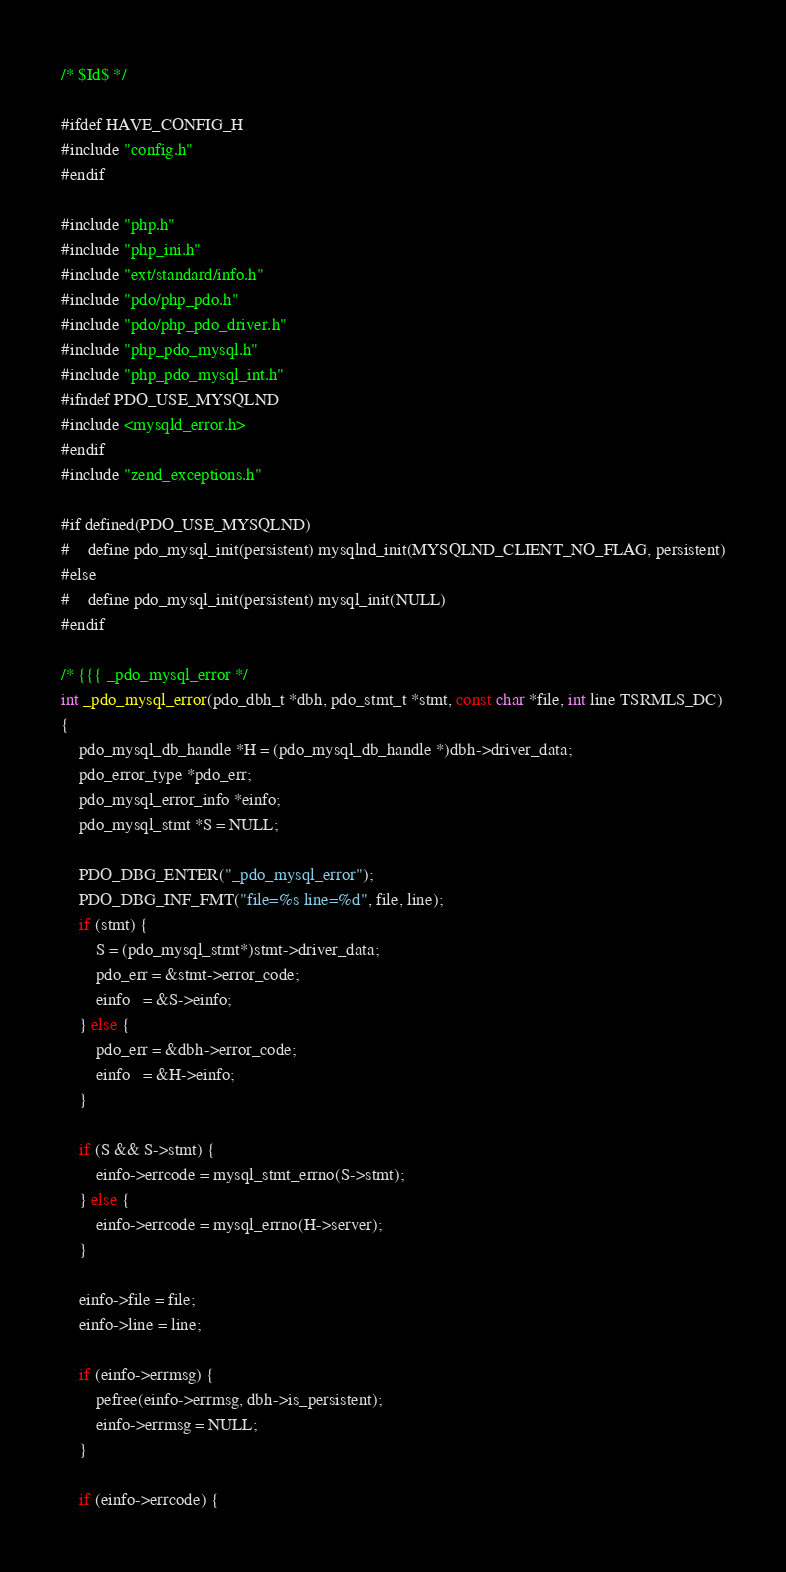<code> <loc_0><loc_0><loc_500><loc_500><_C_>
/* $Id$ */

#ifdef HAVE_CONFIG_H
#include "config.h"
#endif

#include "php.h"
#include "php_ini.h"
#include "ext/standard/info.h"
#include "pdo/php_pdo.h"
#include "pdo/php_pdo_driver.h"
#include "php_pdo_mysql.h"
#include "php_pdo_mysql_int.h"
#ifndef PDO_USE_MYSQLND
#include <mysqld_error.h>
#endif
#include "zend_exceptions.h"

#if defined(PDO_USE_MYSQLND)
#	define pdo_mysql_init(persistent) mysqlnd_init(MYSQLND_CLIENT_NO_FLAG, persistent)
#else
#	define pdo_mysql_init(persistent) mysql_init(NULL)
#endif

/* {{{ _pdo_mysql_error */
int _pdo_mysql_error(pdo_dbh_t *dbh, pdo_stmt_t *stmt, const char *file, int line TSRMLS_DC)
{
	pdo_mysql_db_handle *H = (pdo_mysql_db_handle *)dbh->driver_data;
	pdo_error_type *pdo_err; 
	pdo_mysql_error_info *einfo;
	pdo_mysql_stmt *S = NULL;

	PDO_DBG_ENTER("_pdo_mysql_error");
	PDO_DBG_INF_FMT("file=%s line=%d", file, line);
	if (stmt) {
		S = (pdo_mysql_stmt*)stmt->driver_data;
		pdo_err = &stmt->error_code;
		einfo   = &S->einfo;
	} else {
		pdo_err = &dbh->error_code;
		einfo   = &H->einfo;
	}

	if (S && S->stmt) {
		einfo->errcode = mysql_stmt_errno(S->stmt);
	} else {
		einfo->errcode = mysql_errno(H->server);
	}

	einfo->file = file;
	einfo->line = line;

	if (einfo->errmsg) {
		pefree(einfo->errmsg, dbh->is_persistent);
		einfo->errmsg = NULL;
	}

	if (einfo->errcode) {</code> 